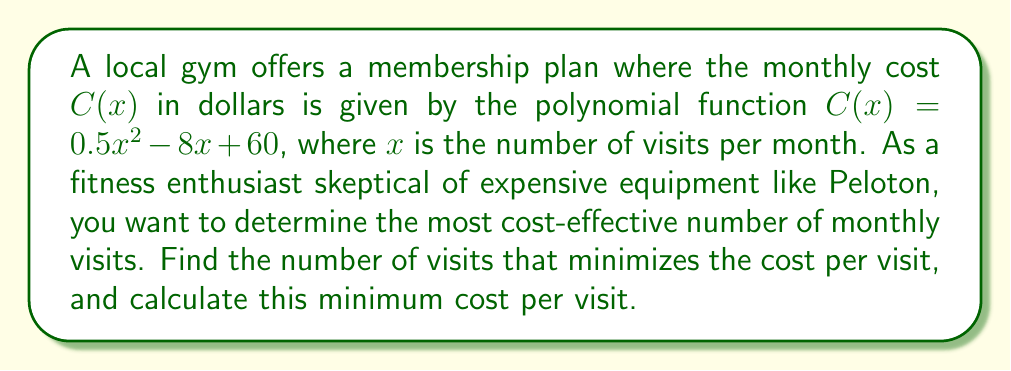Solve this math problem. 1) To find the cost per visit, we divide the total cost by the number of visits:
   $f(x) = \frac{C(x)}{x} = \frac{0.5x^2 - 8x + 60}{x} = 0.5x - 8 + \frac{60}{x}$

2) To minimize $f(x)$, we find where its derivative equals zero:
   $f'(x) = 0.5 - \frac{60}{x^2}$
   Set $f'(x) = 0$:
   $0.5 - \frac{60}{x^2} = 0$

3) Solve for $x$:
   $\frac{60}{x^2} = 0.5$
   $x^2 = 120$
   $x = \sqrt{120} = 2\sqrt{30} \approx 10.95$

4) Since we need a whole number of visits, we'll check both 10 and 11 visits:
   For 10 visits: $f(10) = 0.5(10) - 8 + \frac{60}{10} = 5 - 8 + 6 = 3$
   For 11 visits: $f(11) = 0.5(11) - 8 + \frac{60}{11} \approx 5.5 - 8 + 5.45 = 2.95$

5) Calculate the minimum cost per visit:
   $f(11) \approx 2.95$
Answer: 11 visits; $2.95 per visit 